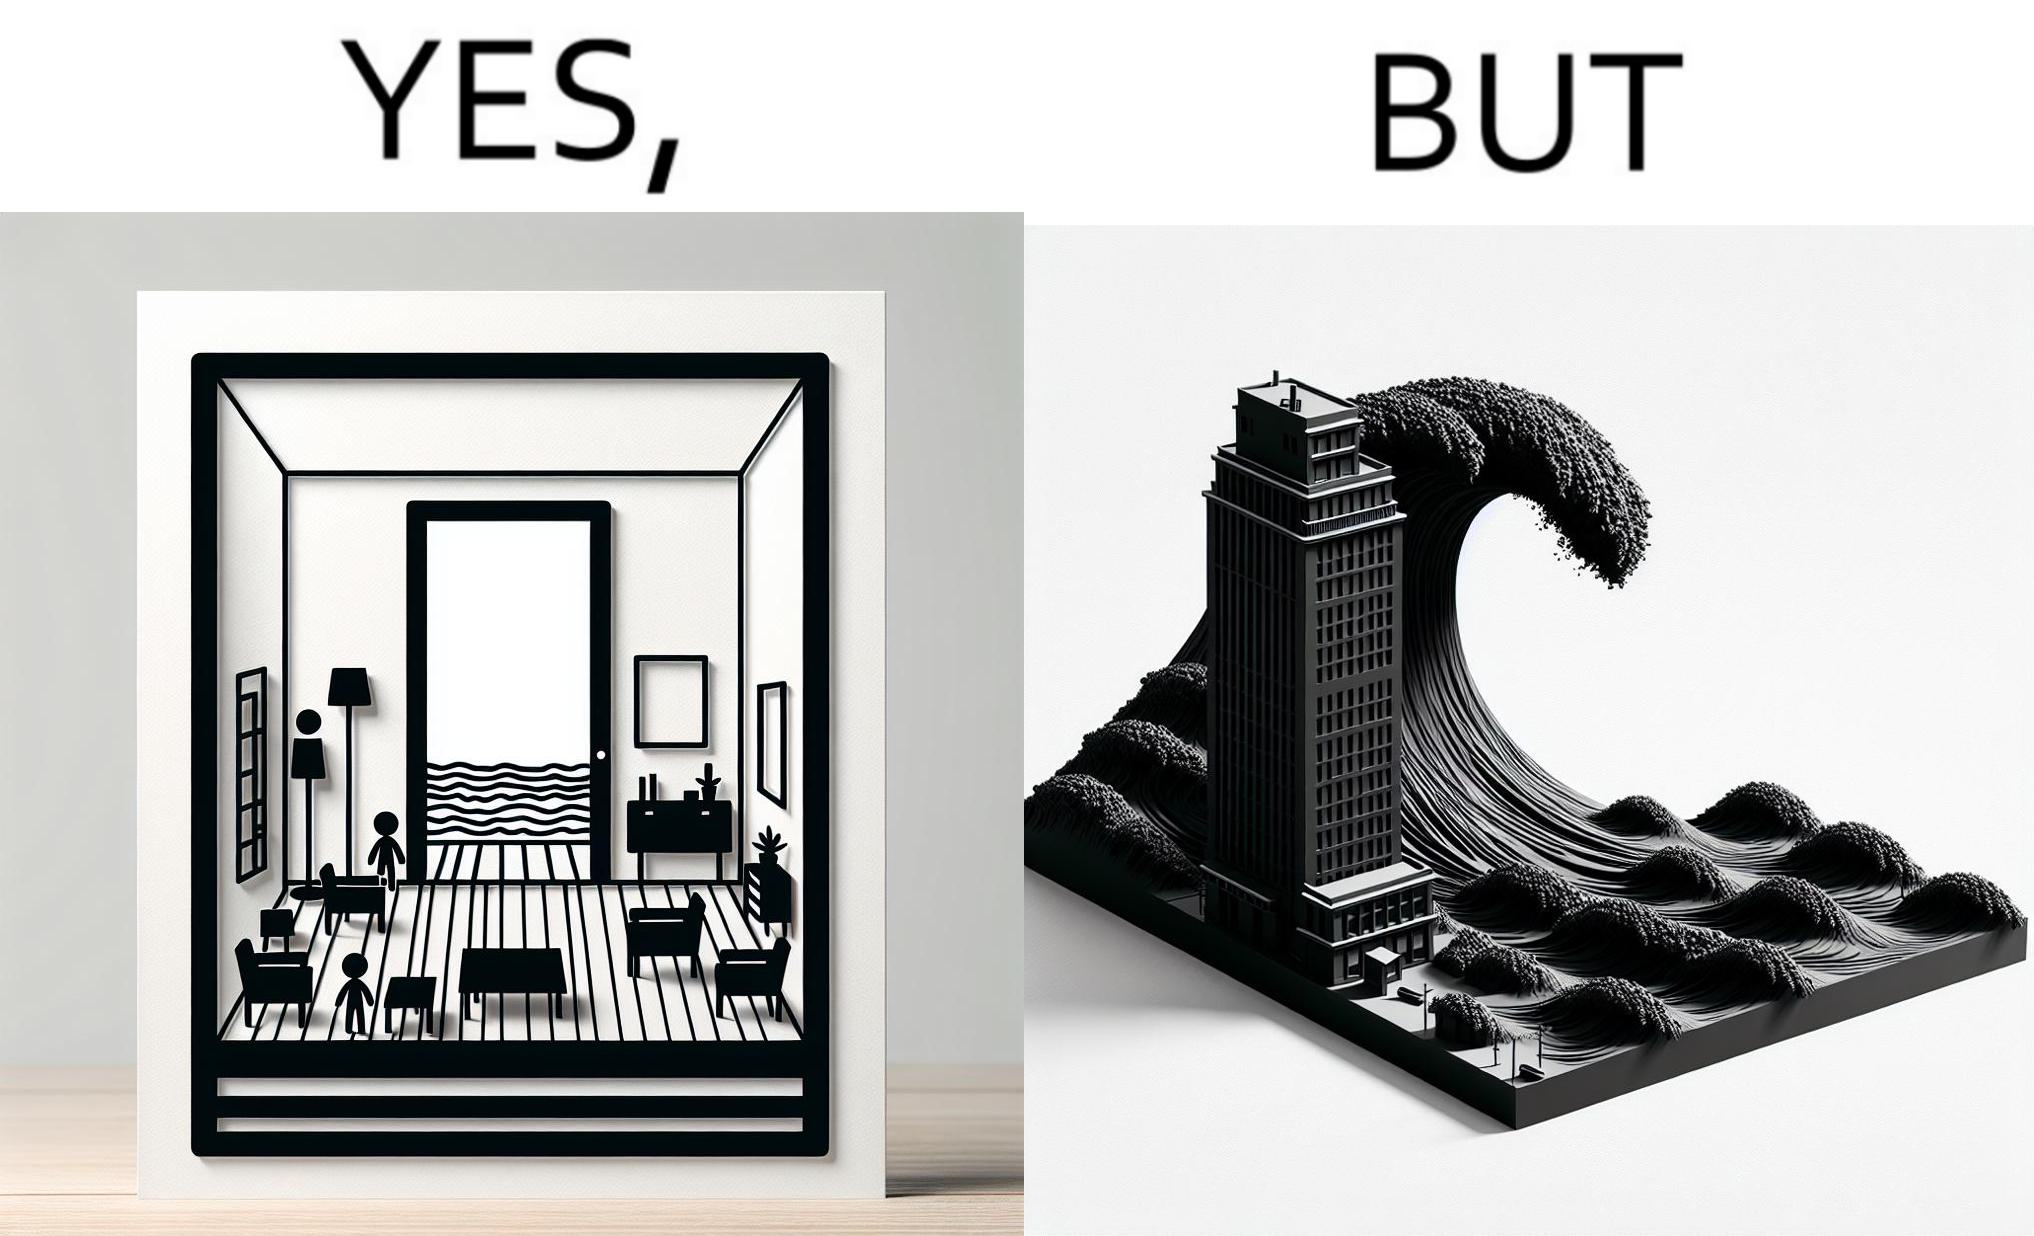Describe what you see in this image. The same sea which gives us a relaxation on a normal day can pose a danger to us sometimes like during a tsunami 